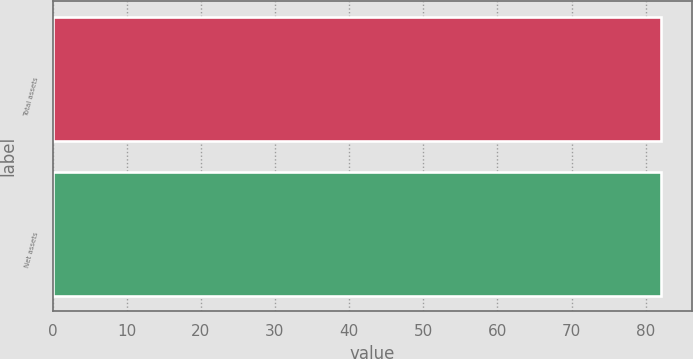Convert chart. <chart><loc_0><loc_0><loc_500><loc_500><bar_chart><fcel>Total assets<fcel>Net assets<nl><fcel>82<fcel>82.1<nl></chart> 